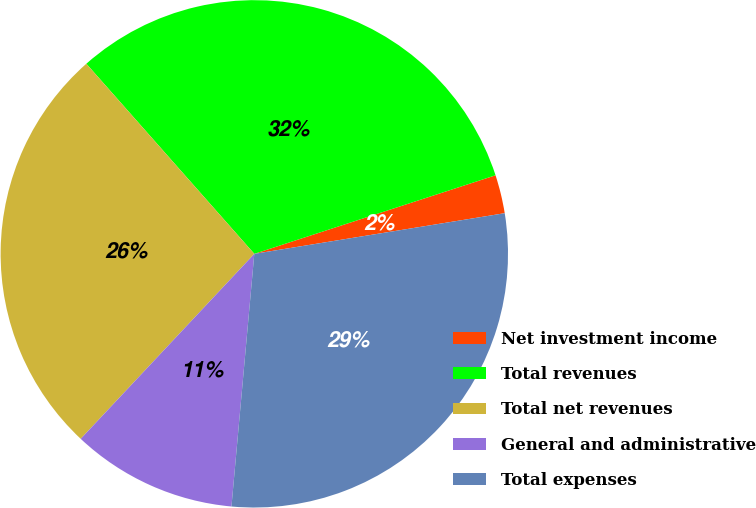<chart> <loc_0><loc_0><loc_500><loc_500><pie_chart><fcel>Net investment income<fcel>Total revenues<fcel>Total net revenues<fcel>General and administrative<fcel>Total expenses<nl><fcel>2.45%<fcel>31.51%<fcel>26.49%<fcel>10.56%<fcel>29.0%<nl></chart> 